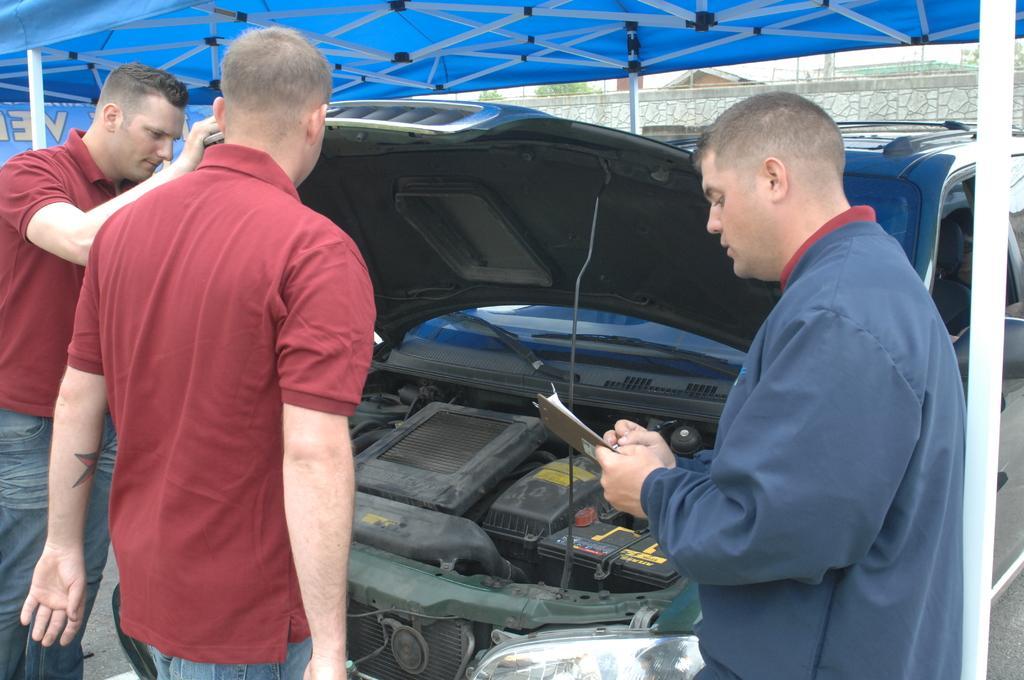Describe this image in one or two sentences. In this image there are three persons are standing in middle of this image and the right side person is holding a pad and one pen, and there is one car in middle of this image and there is a wall in the background. There is a shelter which is in blue color is at top of this image. 